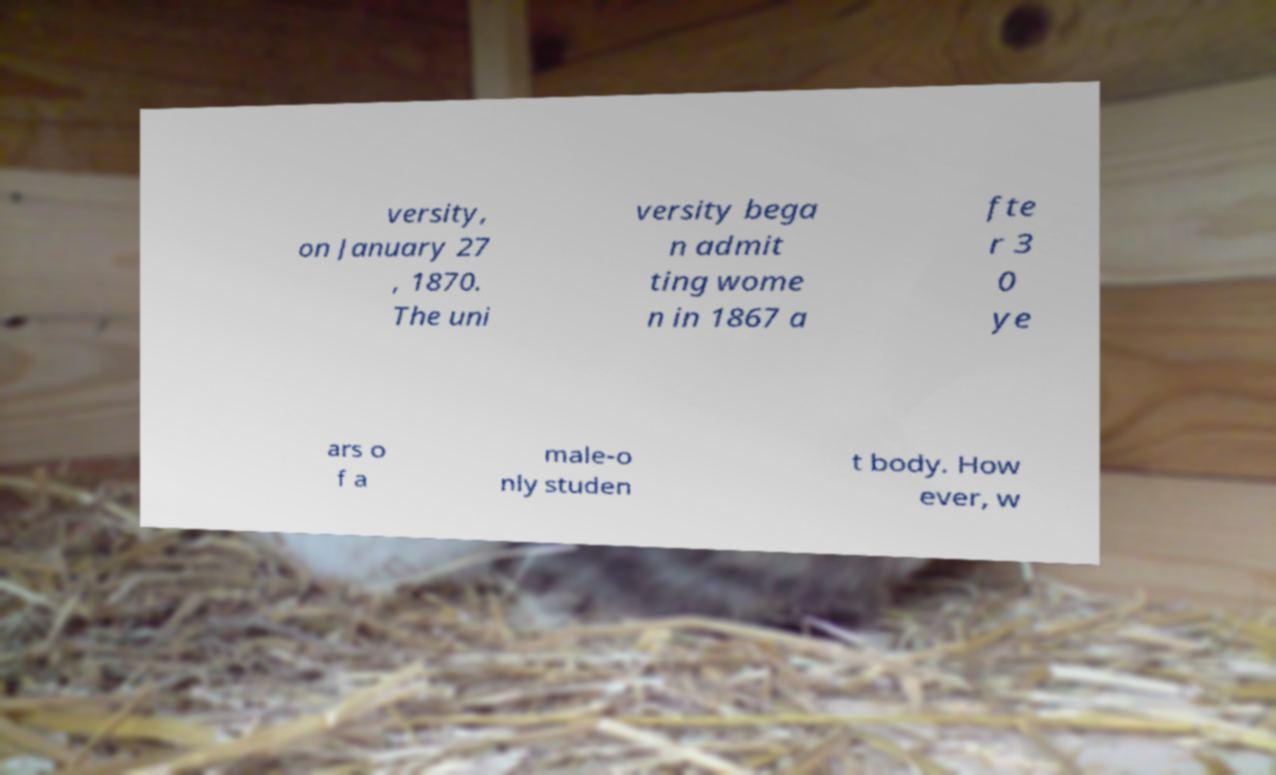Can you accurately transcribe the text from the provided image for me? versity, on January 27 , 1870. The uni versity bega n admit ting wome n in 1867 a fte r 3 0 ye ars o f a male-o nly studen t body. How ever, w 